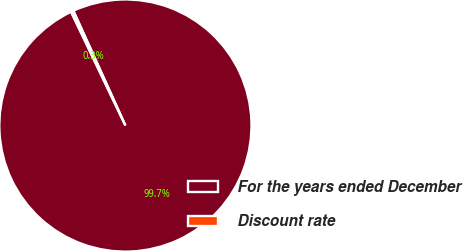Convert chart to OTSL. <chart><loc_0><loc_0><loc_500><loc_500><pie_chart><fcel>For the years ended December<fcel>Discount rate<nl><fcel>99.69%<fcel>0.31%<nl></chart> 